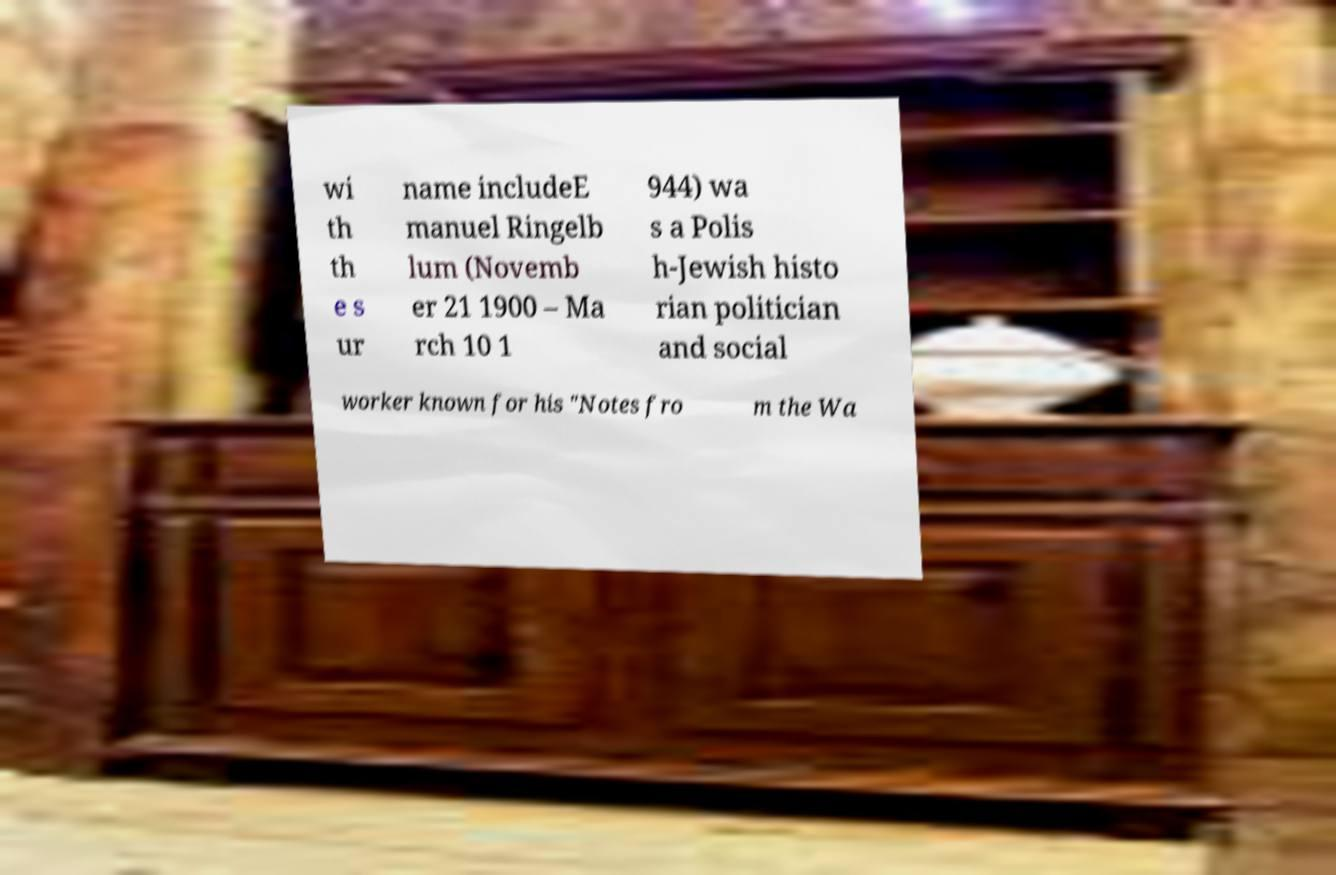I need the written content from this picture converted into text. Can you do that? wi th th e s ur name includeE manuel Ringelb lum (Novemb er 21 1900 – Ma rch 10 1 944) wa s a Polis h-Jewish histo rian politician and social worker known for his "Notes fro m the Wa 